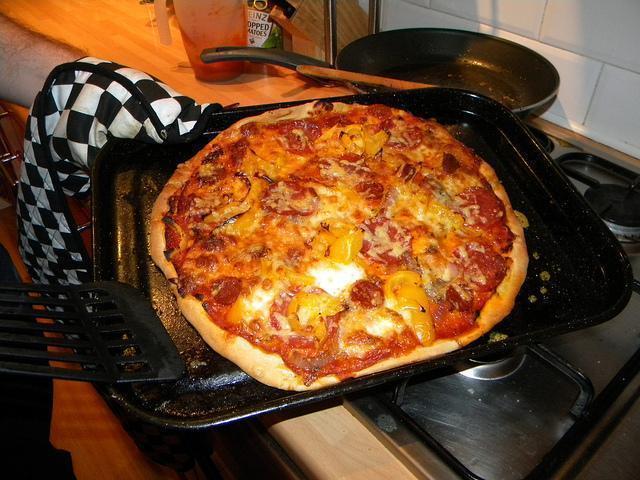The pizza came out of the oven powered by which fuel source?
Make your selection from the four choices given to correctly answer the question.
Options: Propane, charcoal, electricity, natural gas. Natural gas. 